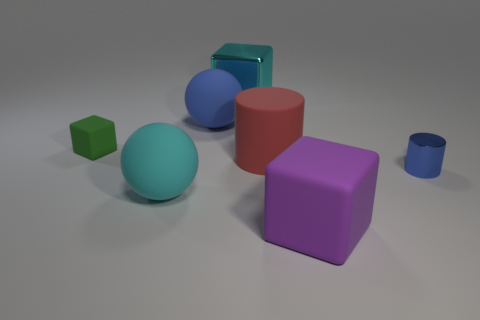What colors are used in this image? The image features a variety of colors including purple, red, blue, green, and cyan, each applied to individual geometric objects against a neutral gray background. Do these colors have any particular significance? In this context, the colors do not appear to have specific significance and are likely chosen for visual contrast and aesthetic appeal, making each shape easily distinguishable from the others. 